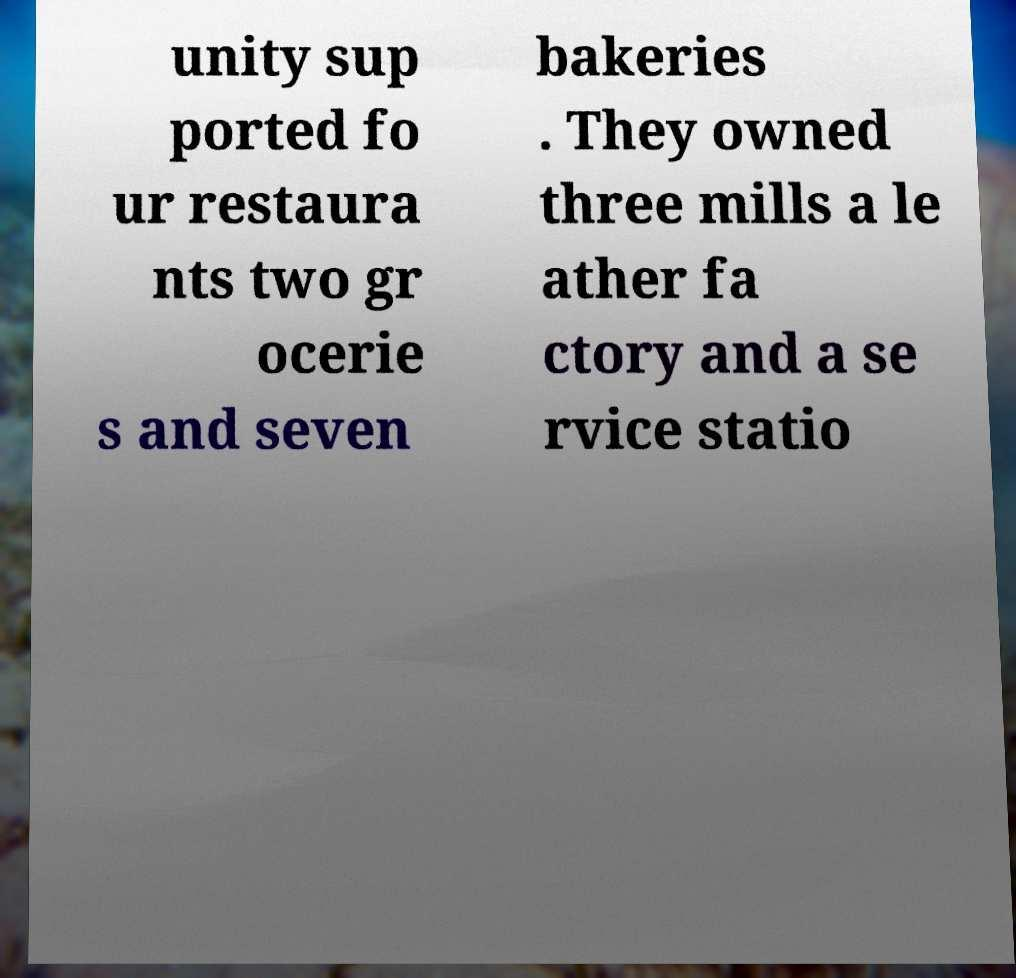Could you assist in decoding the text presented in this image and type it out clearly? unity sup ported fo ur restaura nts two gr ocerie s and seven bakeries . They owned three mills a le ather fa ctory and a se rvice statio 